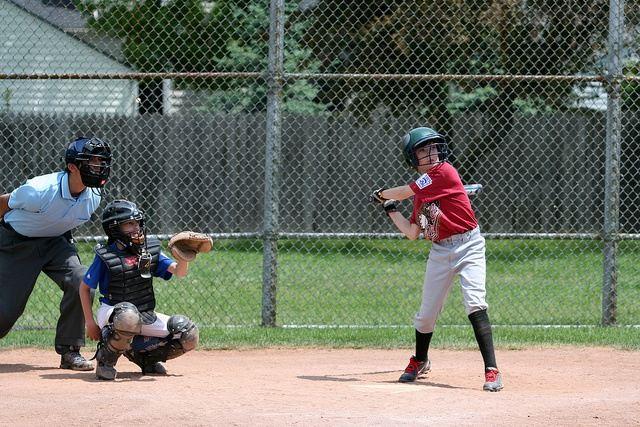Describe the objects in this image and their specific colors. I can see people in gray, darkgray, black, maroon, and white tones, people in gray, black, brown, and darkgray tones, people in gray and black tones, baseball glove in gray, black, maroon, and lightgray tones, and baseball bat in gray, lightgray, darkgray, and lightblue tones in this image. 